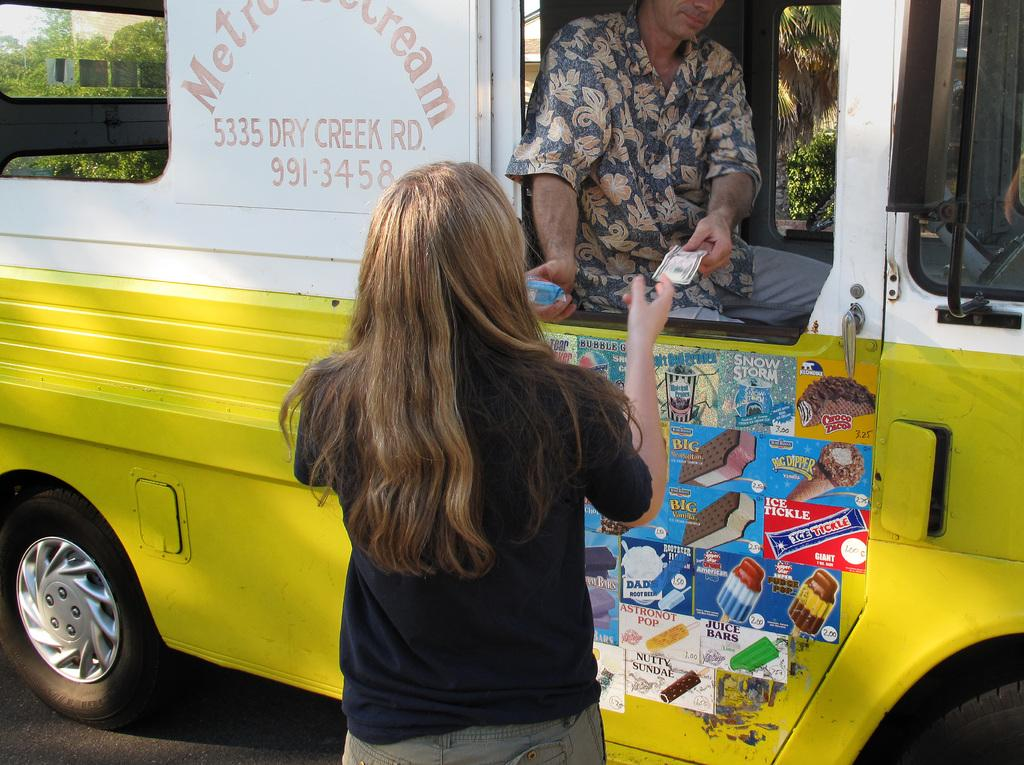What is the main subject of the picture? The main subject of the picture is a vehicle. What is the woman in the picture doing? The woman is collecting ice cream and cash from a person in the vehicle. What colors are visible on the vehicle? The vehicle is in yellow and white color. What historical event is depicted in the image? There is no historical event depicted in the image; it shows a woman collecting ice cream and cash from a person in a yellow and white vehicle. What type of stone can be seen in the image? There is no stone present in the image. 